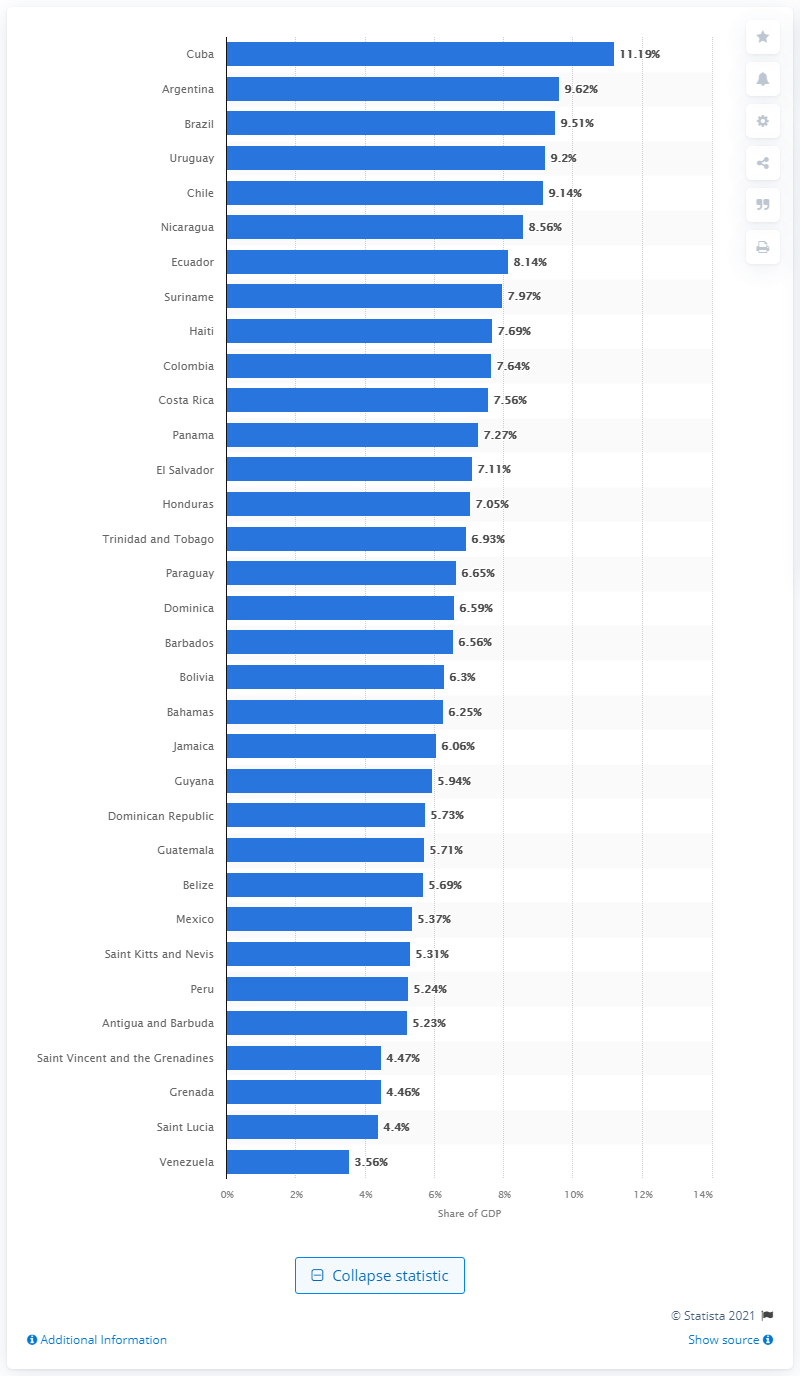Mention a couple of crucial points in this snapshot. Cuba had the highest share of health spending in relation to its GDP in 2018, among all countries. 